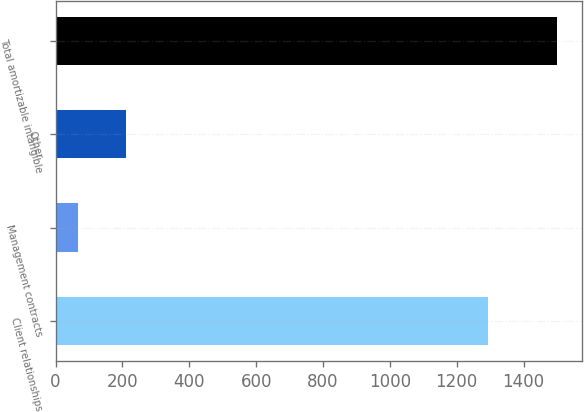Convert chart to OTSL. <chart><loc_0><loc_0><loc_500><loc_500><bar_chart><fcel>Client relationships<fcel>Management contracts<fcel>Other<fcel>Total amortizable intangible<nl><fcel>1293<fcel>67<fcel>210.2<fcel>1499<nl></chart> 